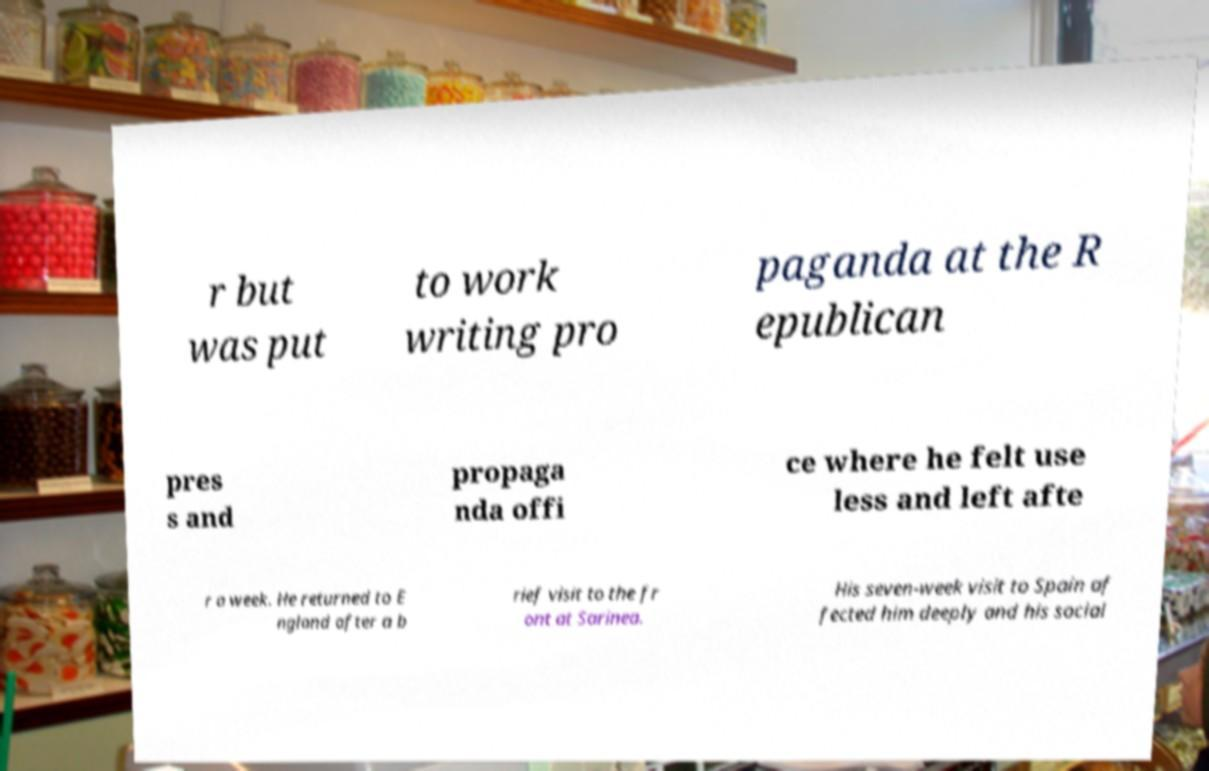Please identify and transcribe the text found in this image. r but was put to work writing pro paganda at the R epublican pres s and propaga nda offi ce where he felt use less and left afte r a week. He returned to E ngland after a b rief visit to the fr ont at Sarinea. His seven-week visit to Spain af fected him deeply and his social 